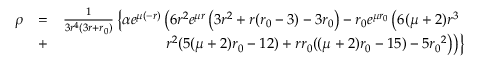Convert formula to latex. <formula><loc_0><loc_0><loc_500><loc_500>\begin{array} { r l r } { \rho } & { = } & { \frac { 1 } { 3 r ^ { 4 } ( 3 r + { r _ { 0 } } ) } \left \{ \alpha e ^ { \mu ( - r ) } \left ( 6 r ^ { 2 } e ^ { \mu r } \left ( 3 r ^ { 2 } + r ( { r _ { 0 } } - 3 ) - 3 { r _ { 0 } } \right ) - { r _ { 0 } } e ^ { \mu { r _ { 0 } } } \left ( 6 ( \mu + 2 ) r ^ { 3 } } \\ & { + } & { r ^ { 2 } ( 5 ( \mu + 2 ) { r _ { 0 } } - 1 2 ) + r { r _ { 0 } } ( ( \mu + 2 ) { r _ { 0 } } - 1 5 ) - 5 { r _ { 0 } } ^ { 2 } \right ) \right ) \right \} } \end{array}</formula> 